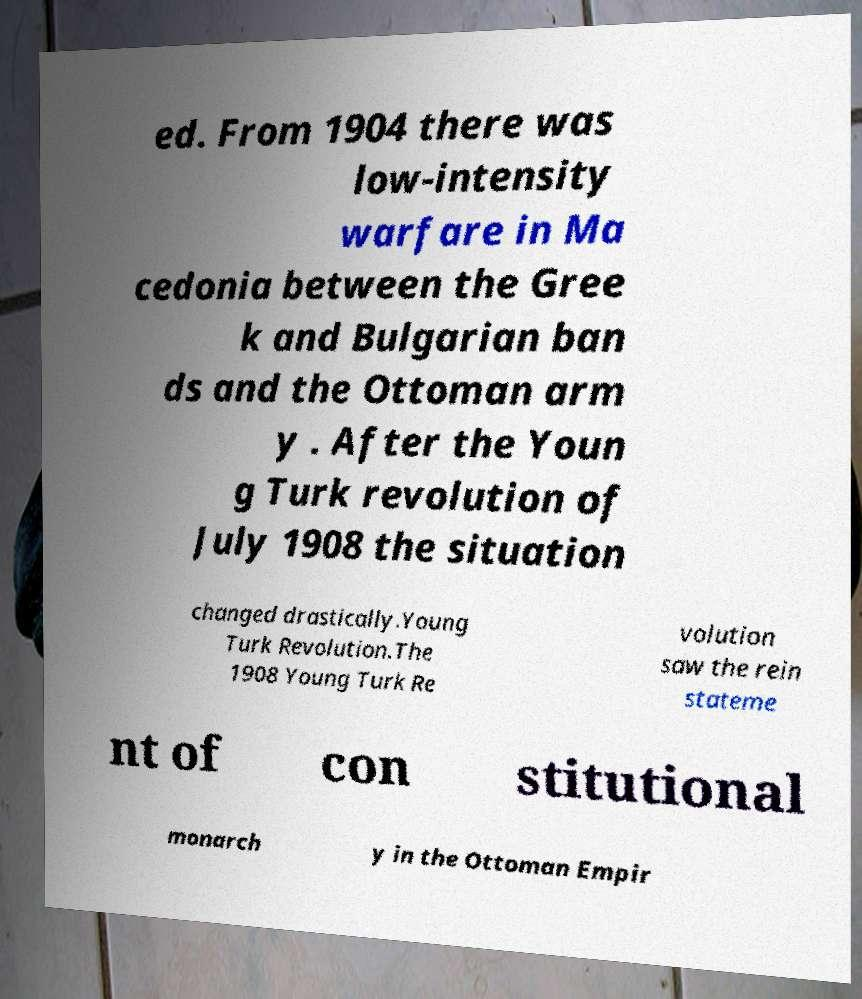Could you extract and type out the text from this image? ed. From 1904 there was low-intensity warfare in Ma cedonia between the Gree k and Bulgarian ban ds and the Ottoman arm y . After the Youn g Turk revolution of July 1908 the situation changed drastically.Young Turk Revolution.The 1908 Young Turk Re volution saw the rein stateme nt of con stitutional monarch y in the Ottoman Empir 